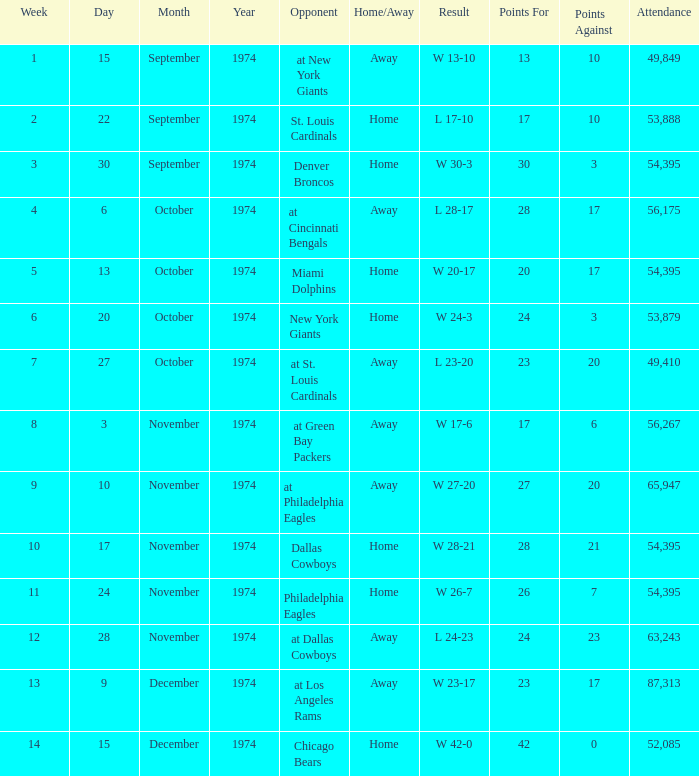What is the week of the game played on November 28, 1974? 12.0. 